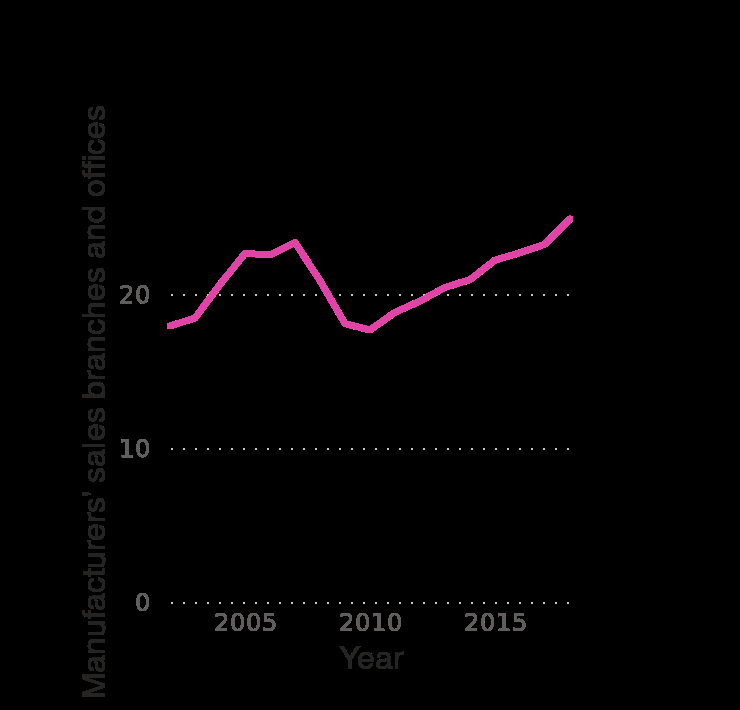<image>
In what year does the x-axis start and end? The x-axis starts at the year 2005 and ends at the year 2015, representing a period of 10 years. 